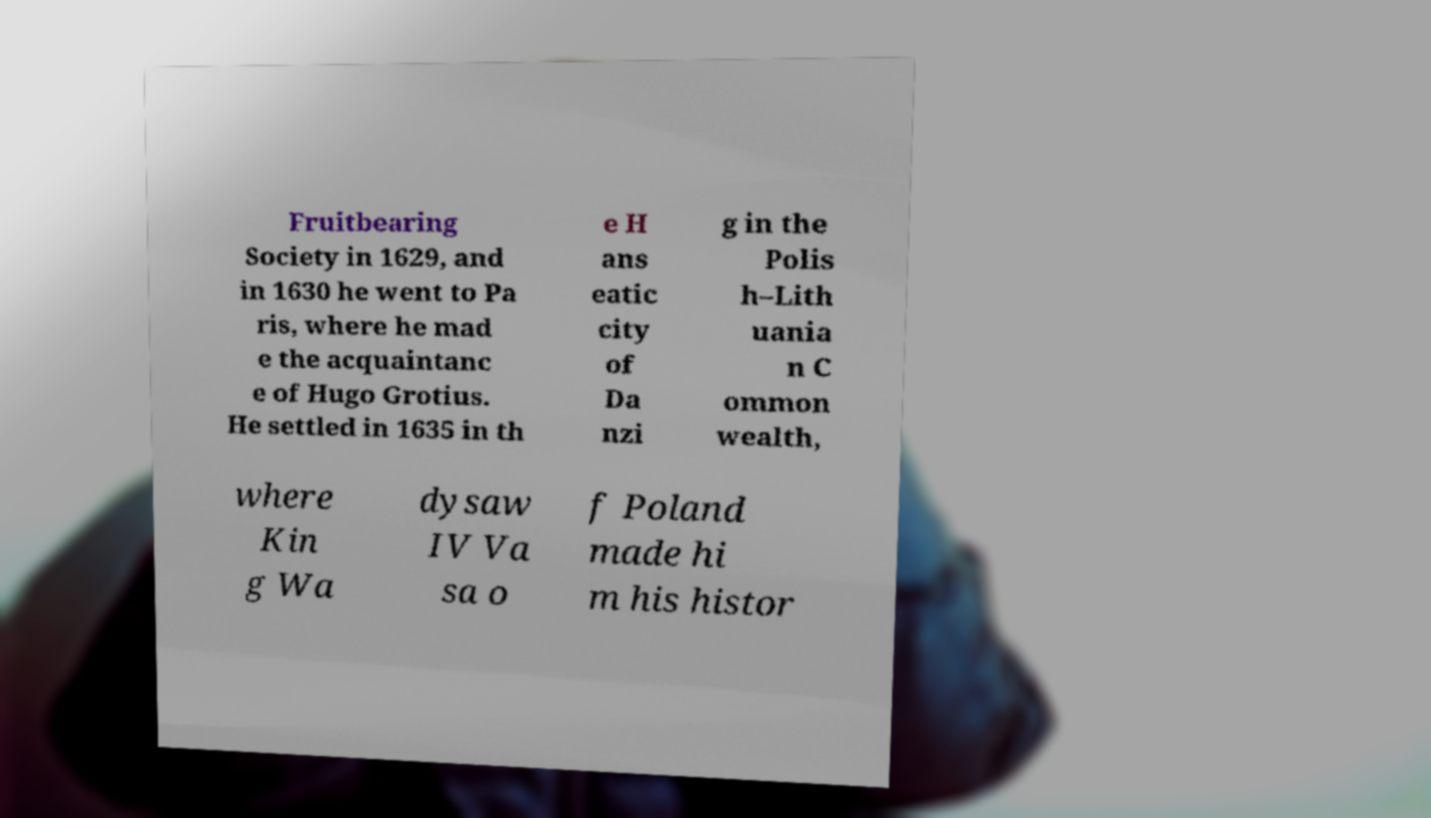What messages or text are displayed in this image? I need them in a readable, typed format. Fruitbearing Society in 1629, and in 1630 he went to Pa ris, where he mad e the acquaintanc e of Hugo Grotius. He settled in 1635 in th e H ans eatic city of Da nzi g in the Polis h–Lith uania n C ommon wealth, where Kin g Wa dysaw IV Va sa o f Poland made hi m his histor 